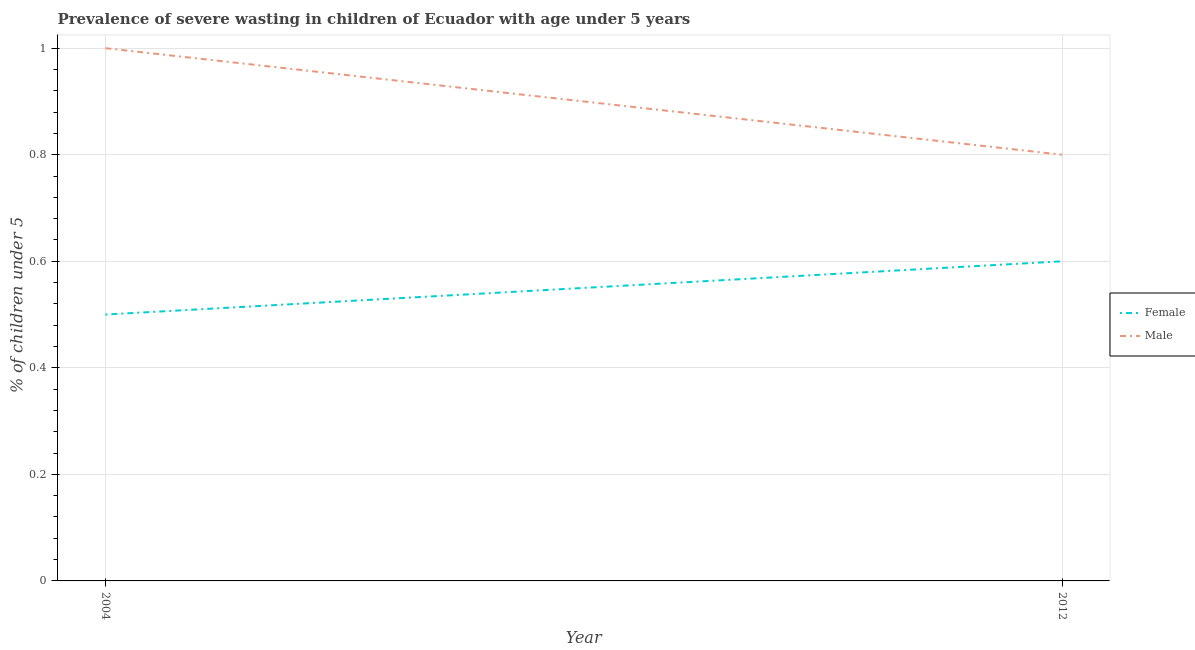Does the line corresponding to percentage of undernourished female children intersect with the line corresponding to percentage of undernourished male children?
Give a very brief answer. No. Is the number of lines equal to the number of legend labels?
Ensure brevity in your answer.  Yes. What is the percentage of undernourished male children in 2004?
Provide a short and direct response. 1. Across all years, what is the maximum percentage of undernourished female children?
Offer a very short reply. 0.6. Across all years, what is the minimum percentage of undernourished female children?
Offer a very short reply. 0.5. In which year was the percentage of undernourished male children minimum?
Your response must be concise. 2012. What is the total percentage of undernourished female children in the graph?
Keep it short and to the point. 1.1. What is the difference between the percentage of undernourished female children in 2004 and that in 2012?
Offer a very short reply. -0.1. What is the difference between the percentage of undernourished male children in 2004 and the percentage of undernourished female children in 2012?
Offer a terse response. 0.4. What is the average percentage of undernourished female children per year?
Offer a very short reply. 0.55. In the year 2004, what is the difference between the percentage of undernourished female children and percentage of undernourished male children?
Offer a very short reply. -0.5. In how many years, is the percentage of undernourished male children greater than 0.2 %?
Give a very brief answer. 2. What is the ratio of the percentage of undernourished female children in 2004 to that in 2012?
Offer a very short reply. 0.83. Is the percentage of undernourished male children in 2004 less than that in 2012?
Provide a short and direct response. No. In how many years, is the percentage of undernourished female children greater than the average percentage of undernourished female children taken over all years?
Make the answer very short. 1. Does the percentage of undernourished female children monotonically increase over the years?
Provide a succinct answer. Yes. How many lines are there?
Ensure brevity in your answer.  2. How many years are there in the graph?
Your response must be concise. 2. How many legend labels are there?
Your response must be concise. 2. How are the legend labels stacked?
Provide a succinct answer. Vertical. What is the title of the graph?
Your response must be concise. Prevalence of severe wasting in children of Ecuador with age under 5 years. What is the label or title of the X-axis?
Make the answer very short. Year. What is the label or title of the Y-axis?
Make the answer very short.  % of children under 5. What is the  % of children under 5 in Female in 2004?
Give a very brief answer. 0.5. What is the  % of children under 5 in Female in 2012?
Ensure brevity in your answer.  0.6. What is the  % of children under 5 in Male in 2012?
Offer a terse response. 0.8. Across all years, what is the maximum  % of children under 5 in Female?
Provide a succinct answer. 0.6. Across all years, what is the minimum  % of children under 5 of Female?
Offer a terse response. 0.5. Across all years, what is the minimum  % of children under 5 of Male?
Offer a very short reply. 0.8. What is the average  % of children under 5 in Female per year?
Give a very brief answer. 0.55. In the year 2004, what is the difference between the  % of children under 5 of Female and  % of children under 5 of Male?
Your response must be concise. -0.5. 